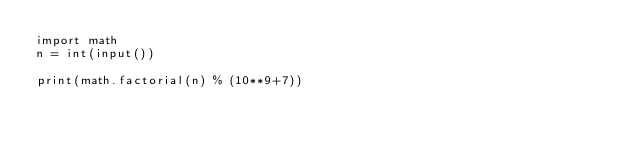<code> <loc_0><loc_0><loc_500><loc_500><_Python_>import math
n = int(input())

print(math.factorial(n) % (10**9+7))</code> 